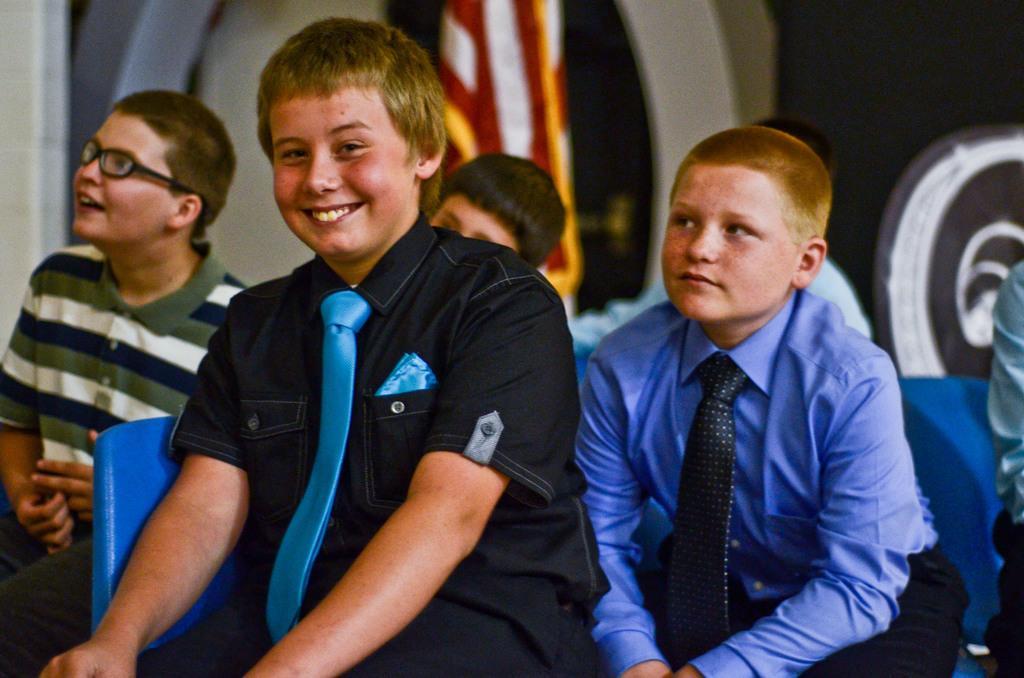Describe this image in one or two sentences. In this picture I can observe boys sitting on the chairs. In the middle of the picture I can observe a boy smiling. The background is blurred. 